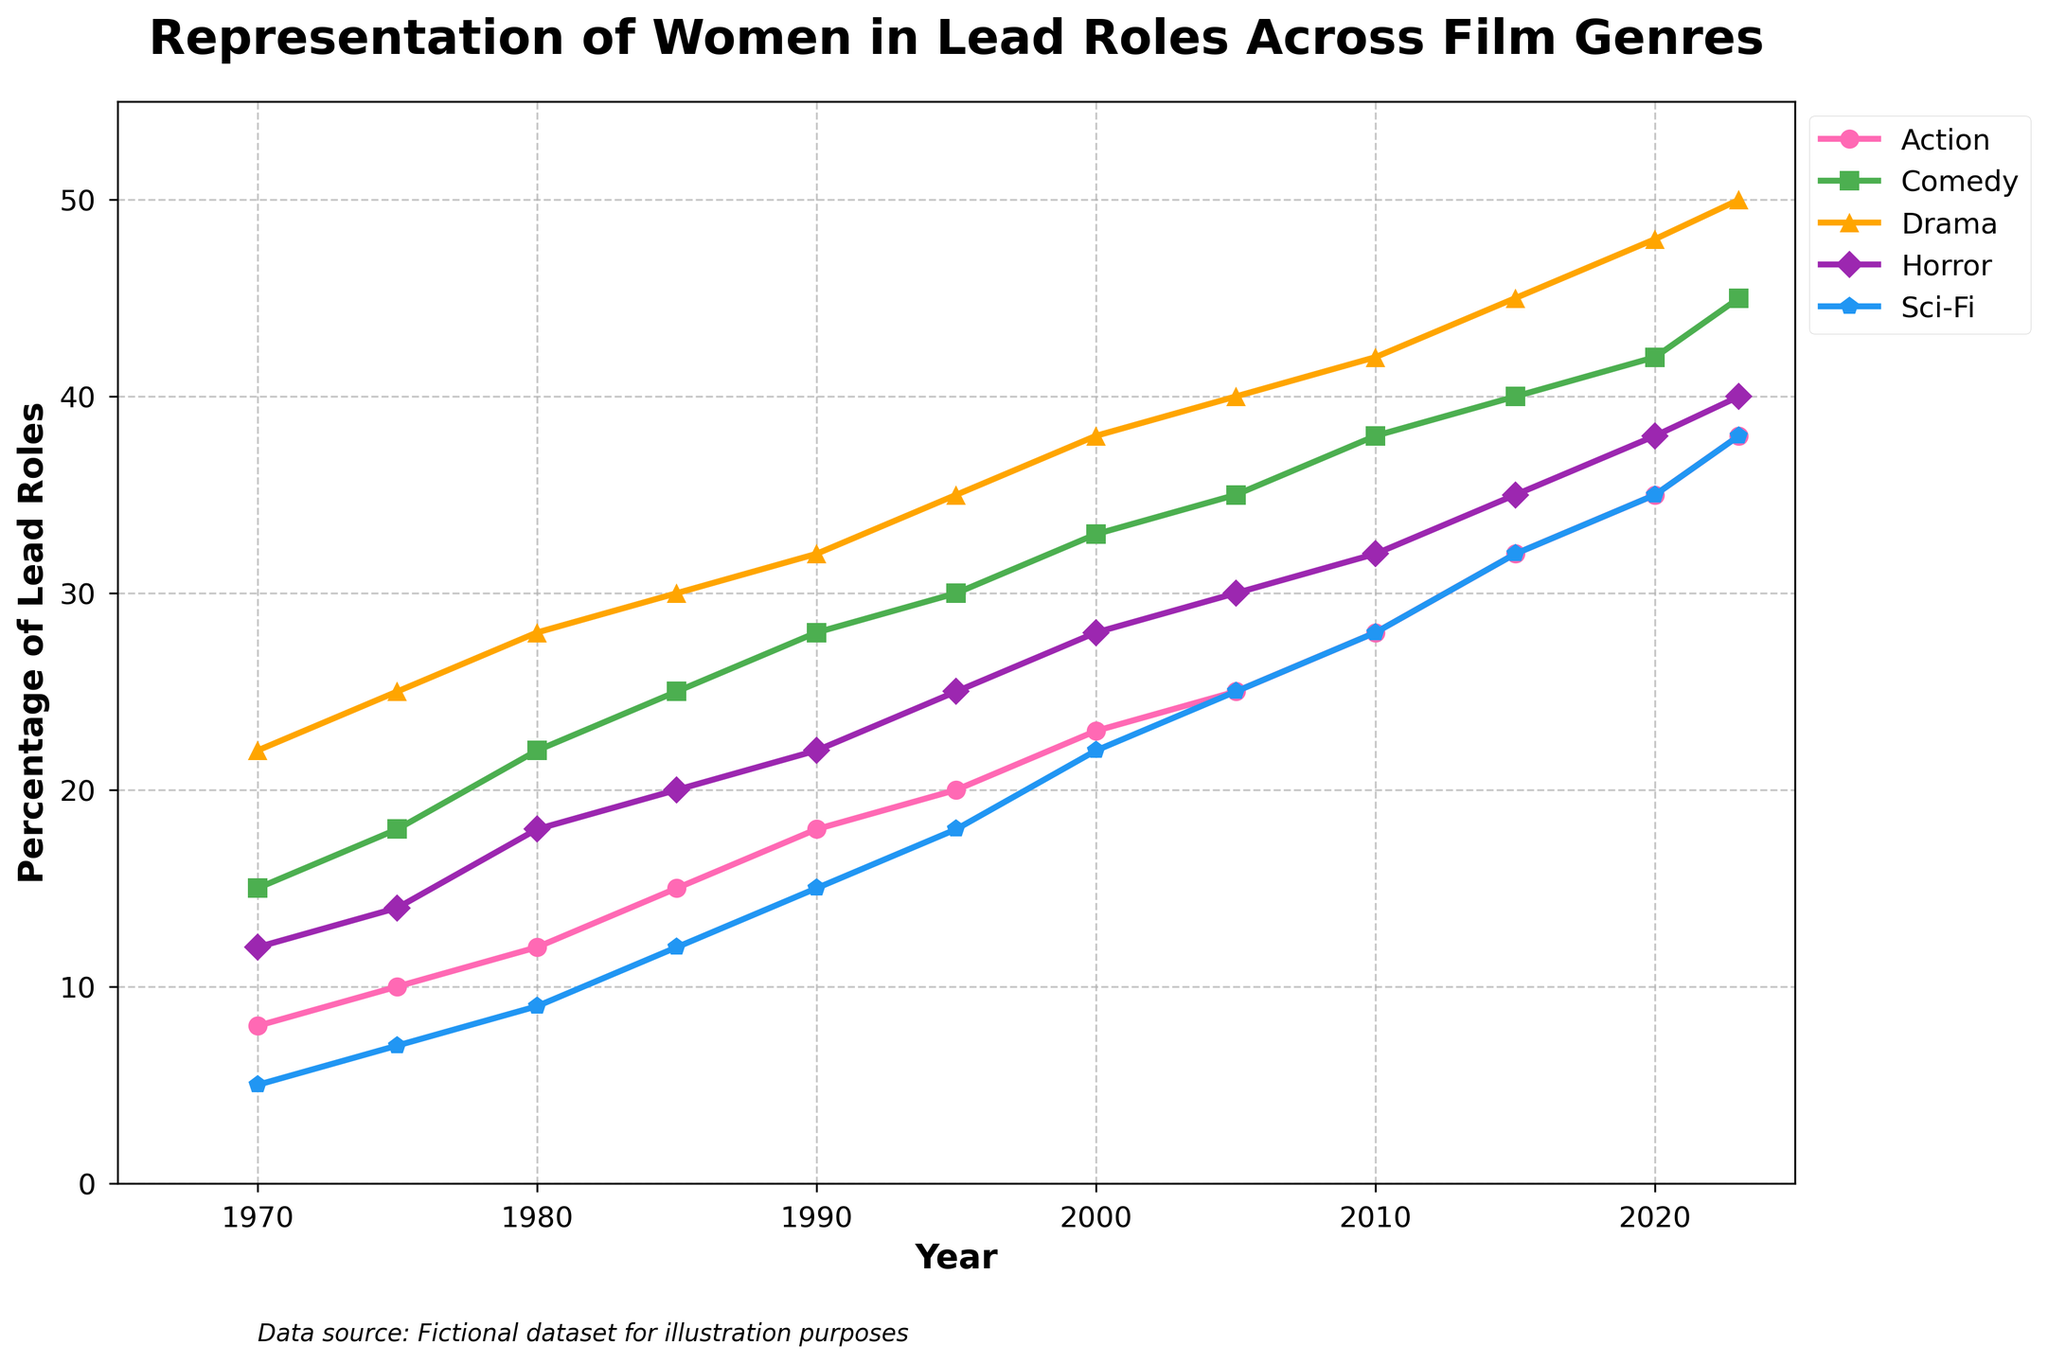What's the trend for the representation of women in lead roles in Sci-Fi films from 1970 to 2023? The Sci-Fi line shows a steadily increasing trend over time, starting at 5% in 1970 and reaching 38% in 2023.
Answer: Steadily increasing trend By how many percentage points did the representation of women in lead roles in Drama films increase from 1970 to 2023? The representation in Drama films was 22% in 1970 and 50% in 2023. The increase is 50% - 22% = 28%.
Answer: 28% Which genre had the highest representation of women in lead roles in 2023? According to the lines in the graph, Drama had the highest representation at 50% in 2023.
Answer: Drama Around which year did Action films see a noticeable increase in the representation of women in lead roles? The Action line shows a steeper incline starting around 1985, where the values begin to rise more sharply from 15%.
Answer: Around 1985 Comparing Comedy and Horror genres, which saw a higher increase in the representation of women in lead roles from 1970 to 2023? Comedy started at 15% in 1970 and reached 45% in 2023, which is an increase of 30%. Horror started at 12% in 1970 and reached 40% in 2023, which is an increase of 28%. So, Comedy saw a higher increase.
Answer: Comedy What's the average representation of women in lead roles in Action films from 1970 to 2023? The representation percentages for Action films are: 8, 10, 12, 15, 18, 20, 23, 25, 28, 32, 35, 38. The sum is 264, and there are 12 data points, so the average is 264/12 = 22%.
Answer: 22% What is the difference in the representation of women in lead roles between Action and Sci-Fi films in 2020? In 2020, Action films had 35% and Sci-Fi films had 35%. The difference is 35% - 35% = 0%.
Answer: 0% Which genre had the most stable increase in the representation of women in lead roles over the years? All genres show an increase over time, but Comedy shows a more consistent linear increase compared to other genres with less fluctuation.
Answer: Comedy What's the median value of the representation of women in lead roles in Horror films across all shown years? The values for Horror films are: 12, 14, 18, 20, 22, 25, 28, 30, 32, 35, 38, 40. The median value is the average of the 6th and 7th values in the ordered list, which are 25 and 28, so (25+28)/2 = 26.5%.
Answer: 26.5% 